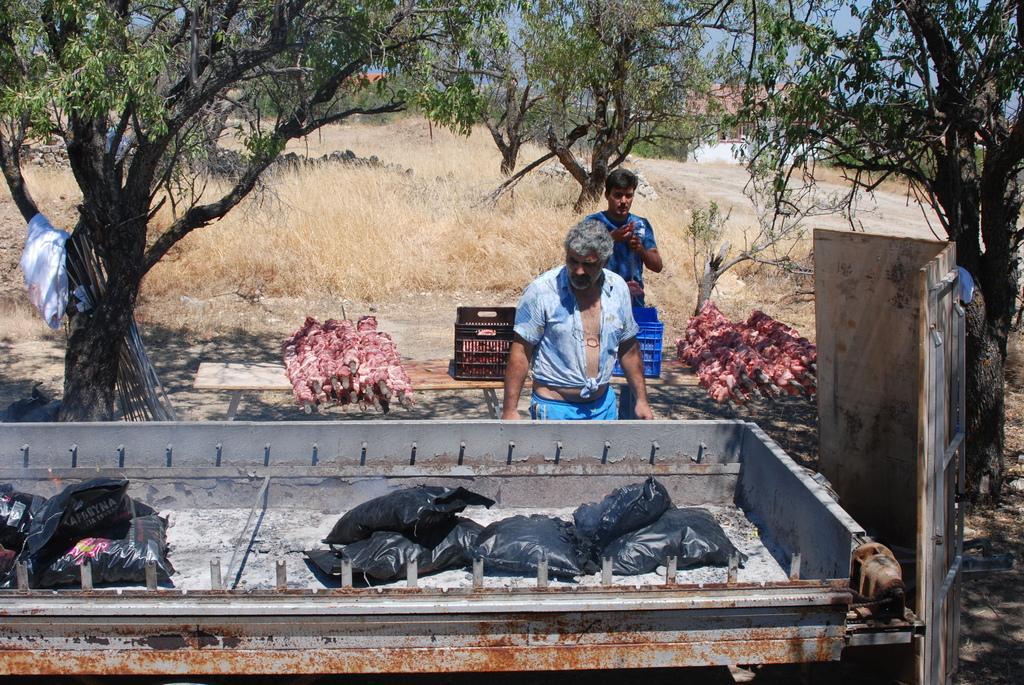In one or two sentences, can you explain what this image depicts? In this picture we can see black packets kept in a metal container. Here we can see 2 people standing on the ground surrounded by trees and grass. On the left side, we can see a wooden board, red meat and plastic boxes. In the background, we can see houses and blue sky. 